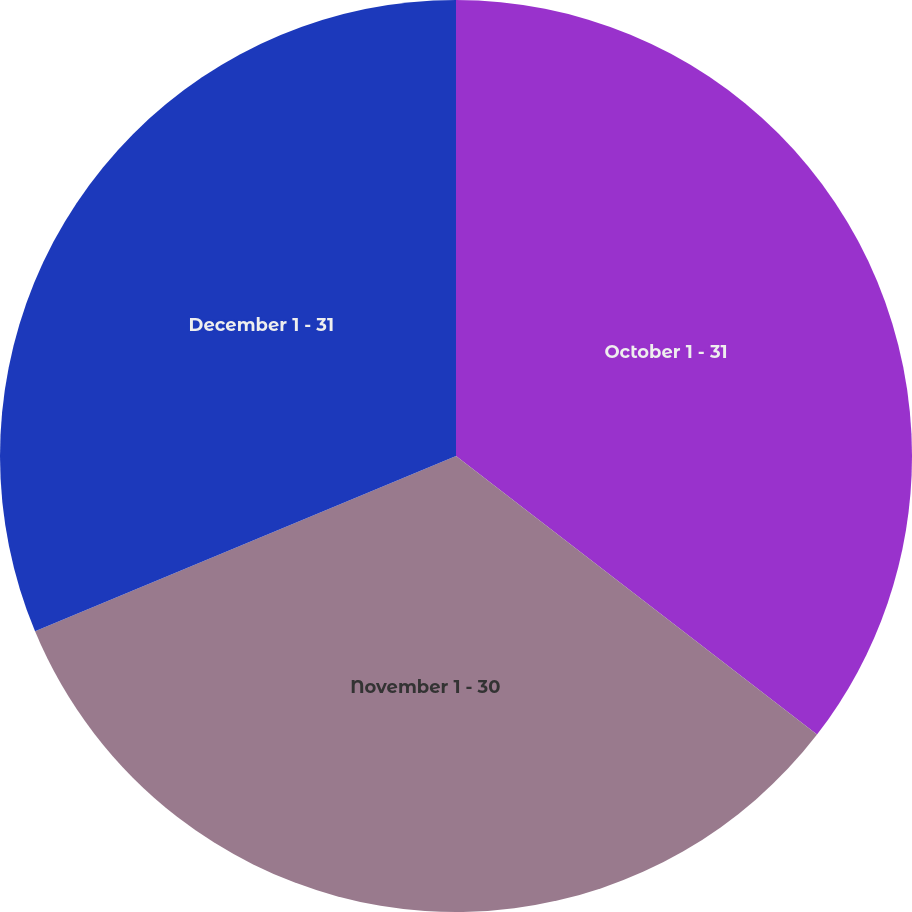Convert chart to OTSL. <chart><loc_0><loc_0><loc_500><loc_500><pie_chart><fcel>October 1 - 31<fcel>November 1 - 30<fcel>December 1 - 31<nl><fcel>35.46%<fcel>33.26%<fcel>31.28%<nl></chart> 